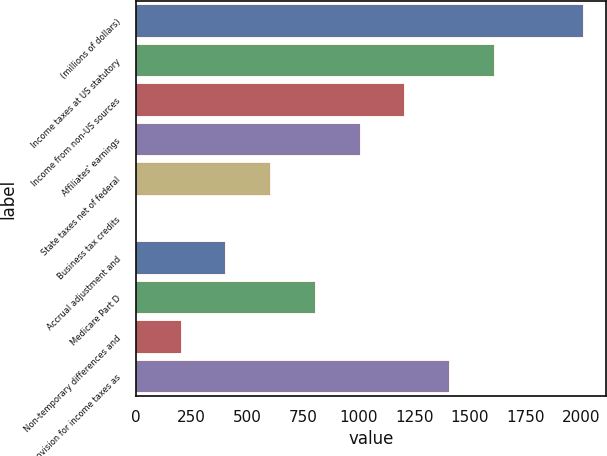<chart> <loc_0><loc_0><loc_500><loc_500><bar_chart><fcel>(millions of dollars)<fcel>Income taxes at US statutory<fcel>Income from non-US sources<fcel>Affiliates' earnings<fcel>State taxes net of federal<fcel>Business tax credits<fcel>Accrual adjustment and<fcel>Medicare Part D<fcel>Non-temporary differences and<fcel>Provision for income taxes as<nl><fcel>2010<fcel>1608.04<fcel>1206.08<fcel>1005.1<fcel>603.14<fcel>0.2<fcel>402.16<fcel>804.12<fcel>201.18<fcel>1407.06<nl></chart> 